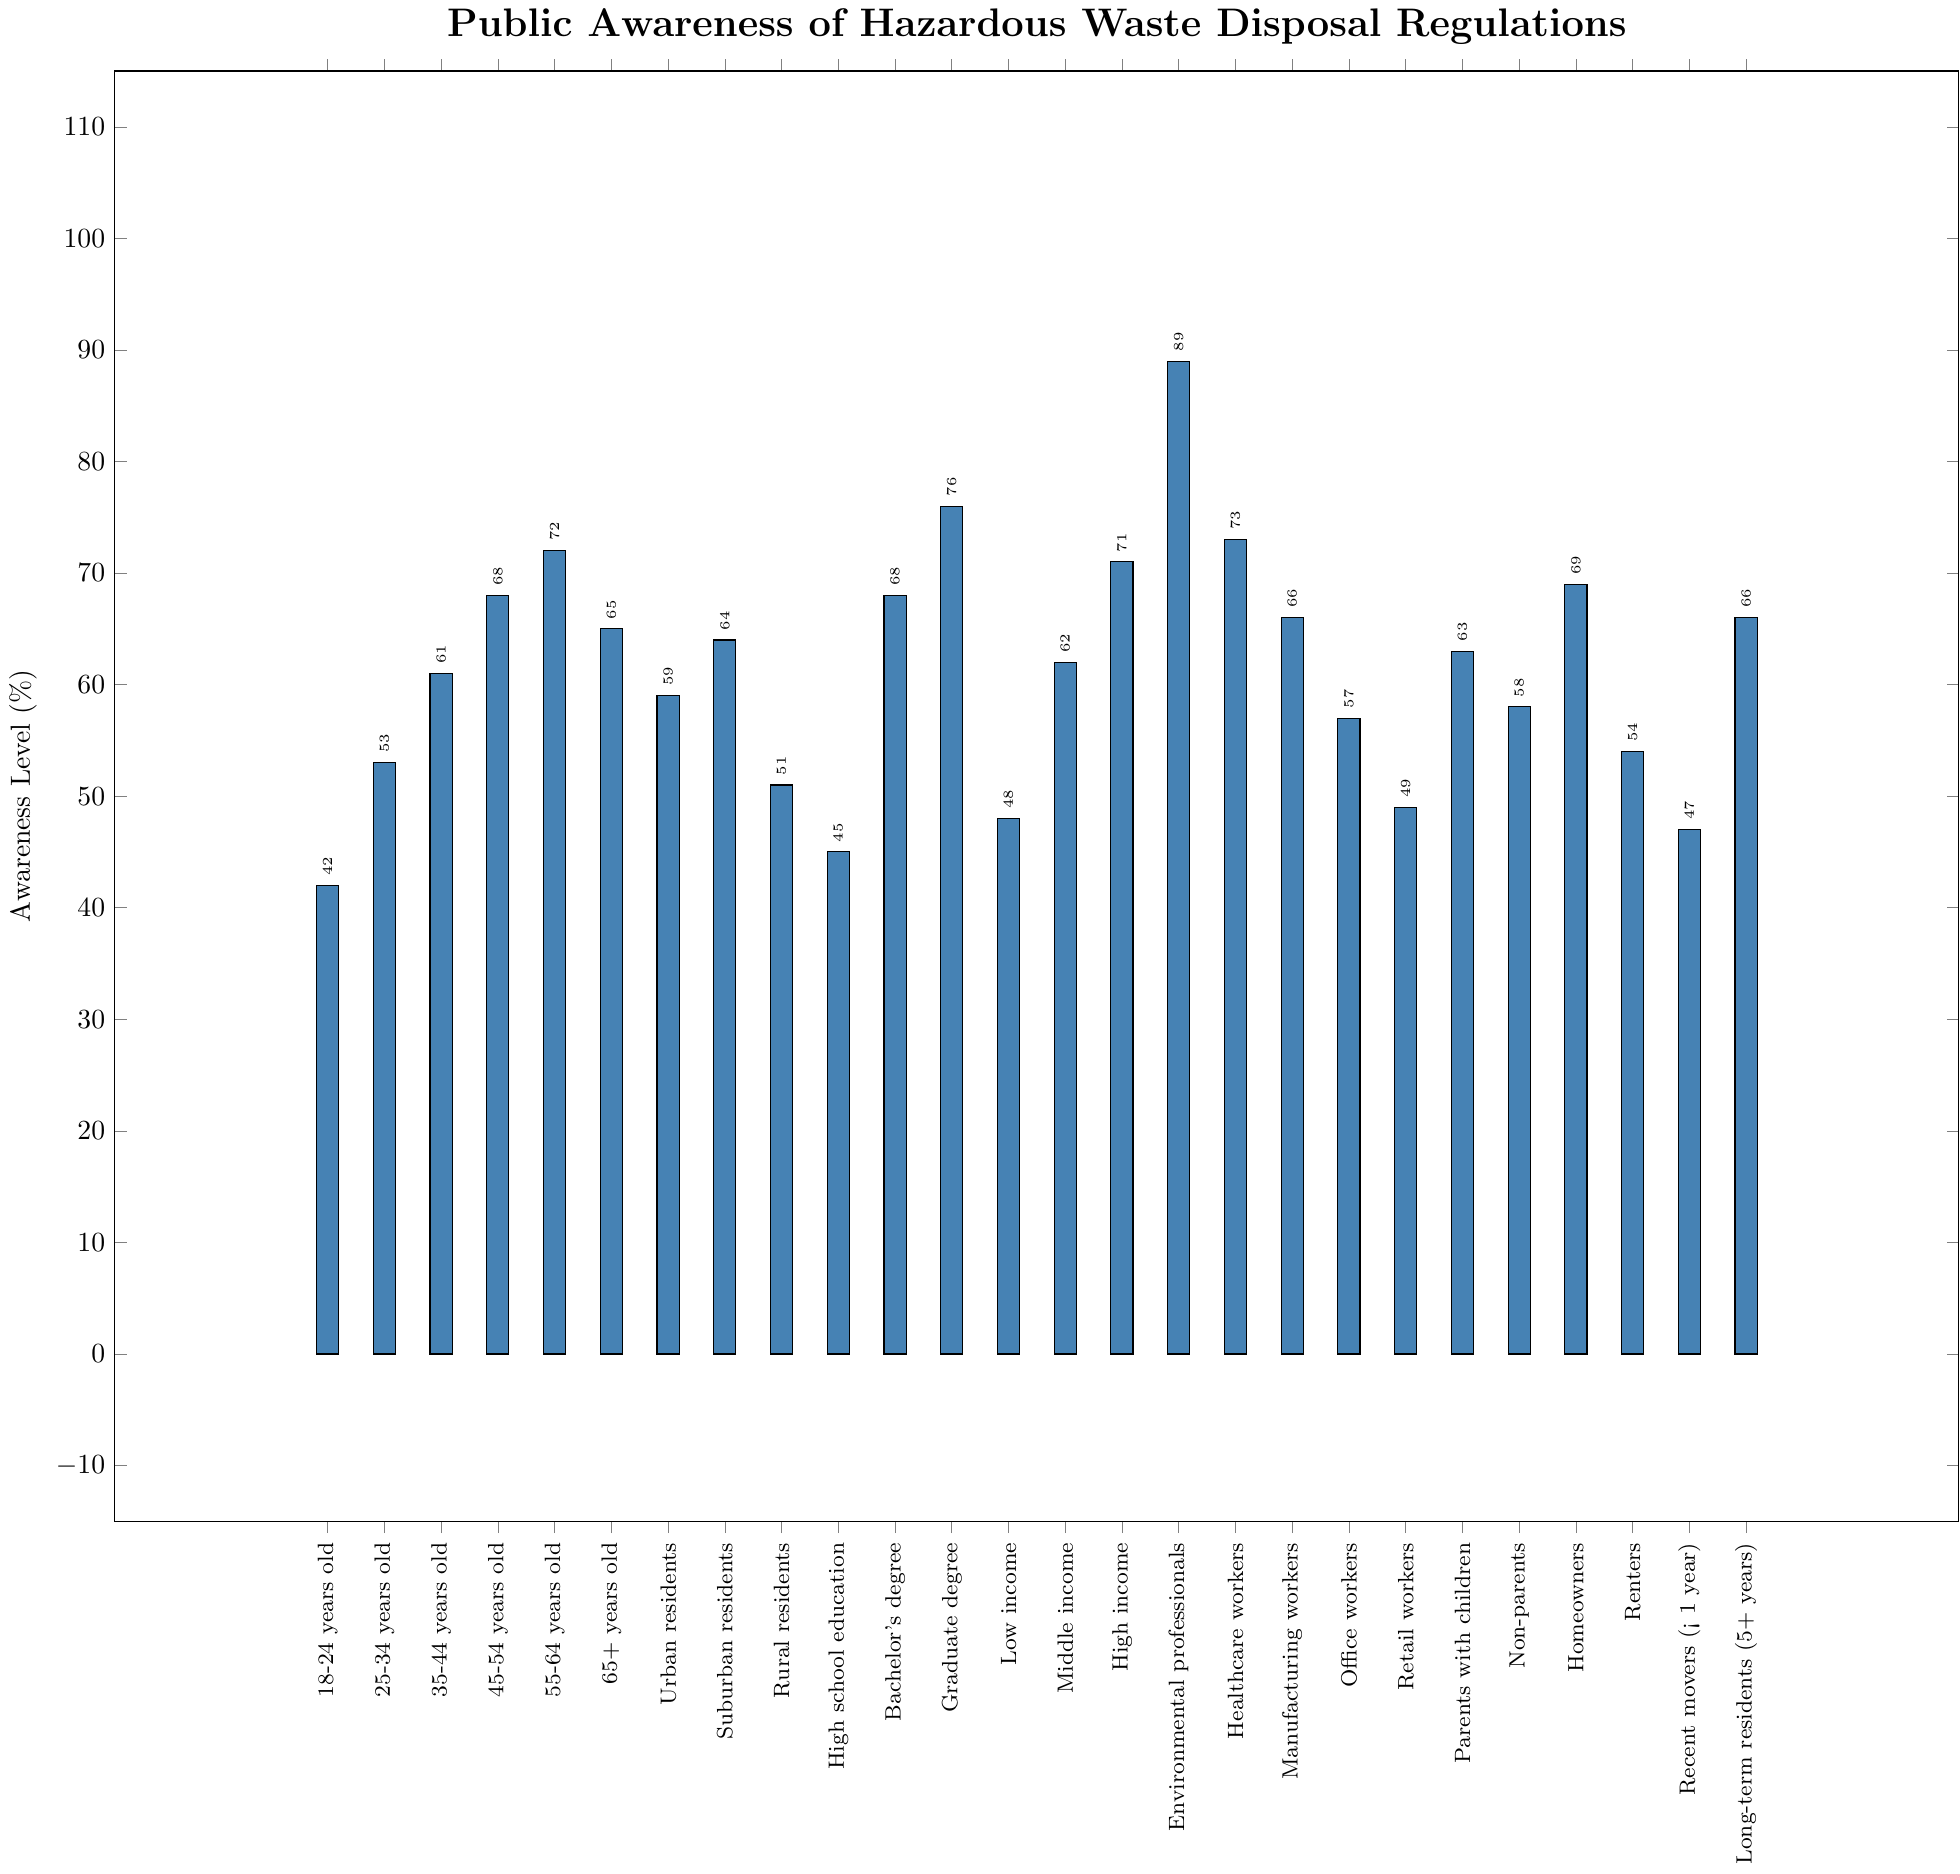Which demographic group has the highest awareness level of hazardous waste disposal regulations? The height of each bar represents the awareness level for each demographic group. The tallest bar corresponds to the "Environmental professionals" group.
Answer: Environmental professionals What is the difference in awareness levels between homeowners and renters? The awareness level for homeowners is 69%, and for renters, it is 54%. The difference is 69% - 54% = 15%.
Answer: 15% Which demographic group has a higher awareness level: rural residents or suburban residents? Look at the bars corresponding to rural and suburban residents. The suburban residents' bar is higher than the rural residents' bar, indicating a higher awareness level.
Answer: Suburban residents What is the average awareness level for the age groups 35-44 years old, 45-54 years old, and 55-64 years old? The awareness levels for the age groups are 61%, 68%, and 72%, respectively. The average is (61 + 68 + 72) / 3 = 67%.
Answer: 67% Is the awareness level of recent movers higher or lower than that of long-term residents? Find the bars for recent movers (< 1 year) and long-term residents (5+ years). The long-term residents' bar is higher, indicating a higher awareness level.
Answer: Lower Compare the awareness levels of healthcare workers and manufacturing workers. Which group has higher awareness? Look at the bars for healthcare workers and manufacturing workers. The healthcare workers' bar is higher.
Answer: Healthcare workers What is the combined awareness level of bachelors and graduate degree holders? The awareness levels are 68% for bachelor's degree holders and 76% for graduate degree holders. The combined awareness level is 68% + 76% = 144%.
Answer: 144% What is the median awareness level for all the listed demographic groups? Arrange all the awareness levels: 42, 45, 47, 48, 49, 51, 53, 54, 57, 58, 59, 61, 62, 63, 64, 65, 66, 66, 68, 68, 69, 71, 72, 73, 76, 89. The median is the middle value, which is 64 between the 13th and 14th values (63 and 64).
Answer: 64 Which group of residents has the highest awareness, and what is that level? Among urban, suburban, and rural residents, suburban residents have the highest awareness at 64%.
Answer: Suburban residents at 64% Do those with high income have higher awareness levels than those with low income? Compare the bars for high-income and low-income groups. The high-income bar is taller, indicating a higher awareness level.
Answer: Yes 